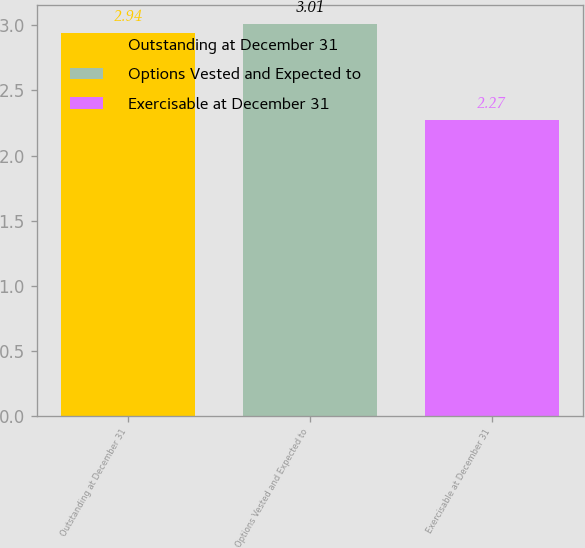Convert chart. <chart><loc_0><loc_0><loc_500><loc_500><bar_chart><fcel>Outstanding at December 31<fcel>Options Vested and Expected to<fcel>Exercisable at December 31<nl><fcel>2.94<fcel>3.01<fcel>2.27<nl></chart> 